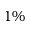<formula> <loc_0><loc_0><loc_500><loc_500>1 \%</formula> 